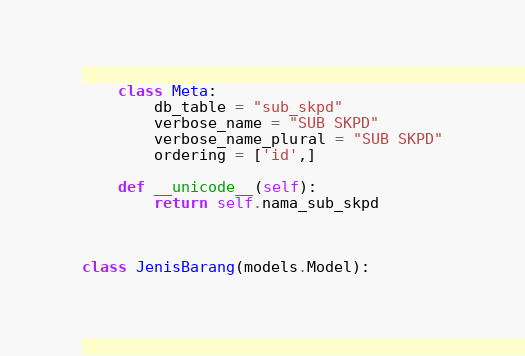<code> <loc_0><loc_0><loc_500><loc_500><_Python_>
    class Meta:
        db_table = "sub_skpd"
        verbose_name = "SUB SKPD"
        verbose_name_plural = "SUB SKPD"
        ordering = ['id',]

    def __unicode__(self):
        return self.nama_sub_skpd



class JenisBarang(models.Model):</code> 